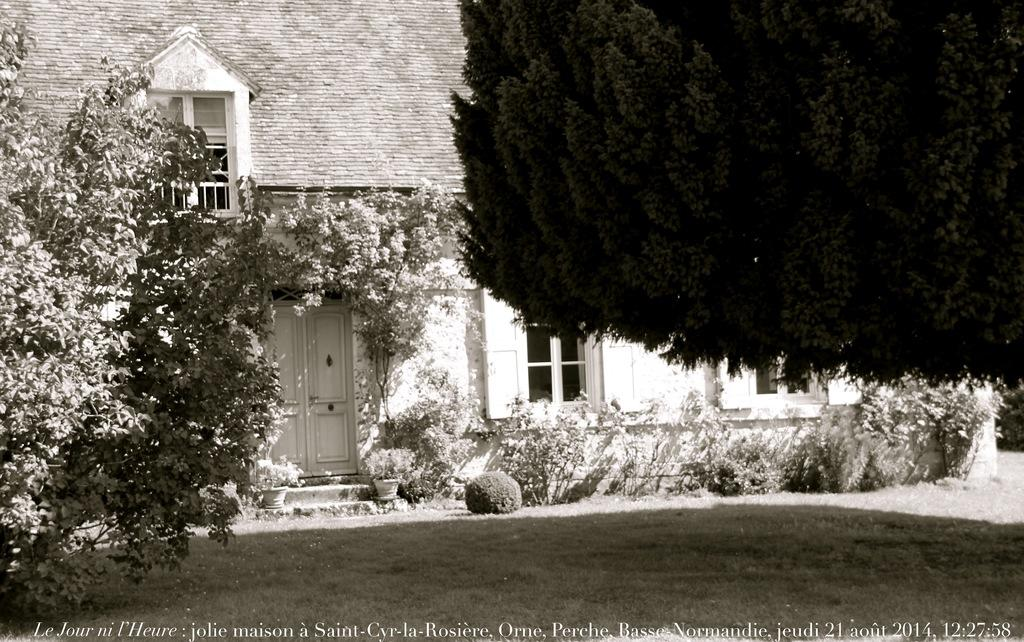What is the color scheme of the image? The image is black and white. What type of structure can be seen in the image? There is a building in the image. What architectural features are visible on the building? There are windows and a door visible on the building. What type of vegetation is present in the image? There are trees, house plants, shrubs, and other plants in the image. What part of the natural environment is visible in the image? The ground is visible in the image. Can you tell me how many times the person in the image smiles? There is no person present in the image, so it is not possible to determine how many times they might smile. 